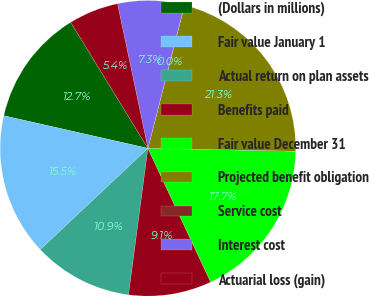<chart> <loc_0><loc_0><loc_500><loc_500><pie_chart><fcel>(Dollars in millions)<fcel>Fair value January 1<fcel>Actual return on plan assets<fcel>Benefits paid<fcel>Fair value December 31<fcel>Projected benefit obligation<fcel>Service cost<fcel>Interest cost<fcel>Actuarial loss (gain)<nl><fcel>12.71%<fcel>15.55%<fcel>10.89%<fcel>9.08%<fcel>17.7%<fcel>21.33%<fcel>0.02%<fcel>7.27%<fcel>5.45%<nl></chart> 